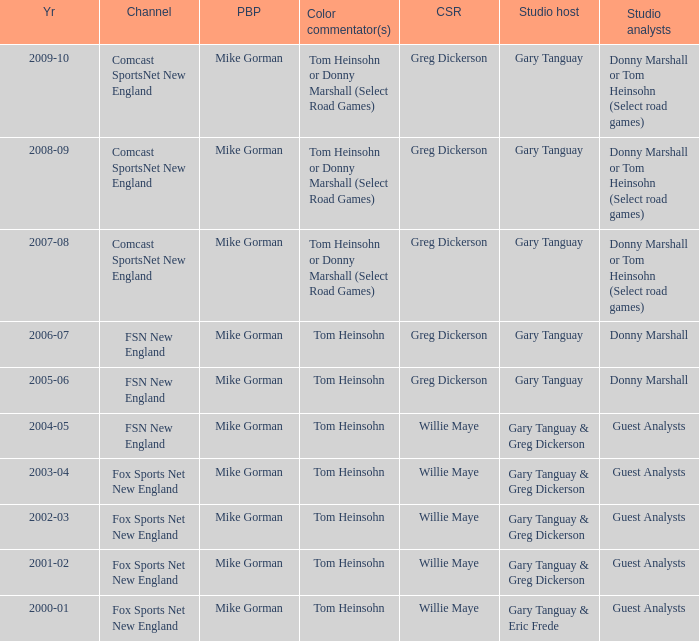Help me parse the entirety of this table. {'header': ['Yr', 'Channel', 'PBP', 'Color commentator(s)', 'CSR', 'Studio host', 'Studio analysts'], 'rows': [['2009-10', 'Comcast SportsNet New England', 'Mike Gorman', 'Tom Heinsohn or Donny Marshall (Select Road Games)', 'Greg Dickerson', 'Gary Tanguay', 'Donny Marshall or Tom Heinsohn (Select road games)'], ['2008-09', 'Comcast SportsNet New England', 'Mike Gorman', 'Tom Heinsohn or Donny Marshall (Select Road Games)', 'Greg Dickerson', 'Gary Tanguay', 'Donny Marshall or Tom Heinsohn (Select road games)'], ['2007-08', 'Comcast SportsNet New England', 'Mike Gorman', 'Tom Heinsohn or Donny Marshall (Select Road Games)', 'Greg Dickerson', 'Gary Tanguay', 'Donny Marshall or Tom Heinsohn (Select road games)'], ['2006-07', 'FSN New England', 'Mike Gorman', 'Tom Heinsohn', 'Greg Dickerson', 'Gary Tanguay', 'Donny Marshall'], ['2005-06', 'FSN New England', 'Mike Gorman', 'Tom Heinsohn', 'Greg Dickerson', 'Gary Tanguay', 'Donny Marshall'], ['2004-05', 'FSN New England', 'Mike Gorman', 'Tom Heinsohn', 'Willie Maye', 'Gary Tanguay & Greg Dickerson', 'Guest Analysts'], ['2003-04', 'Fox Sports Net New England', 'Mike Gorman', 'Tom Heinsohn', 'Willie Maye', 'Gary Tanguay & Greg Dickerson', 'Guest Analysts'], ['2002-03', 'Fox Sports Net New England', 'Mike Gorman', 'Tom Heinsohn', 'Willie Maye', 'Gary Tanguay & Greg Dickerson', 'Guest Analysts'], ['2001-02', 'Fox Sports Net New England', 'Mike Gorman', 'Tom Heinsohn', 'Willie Maye', 'Gary Tanguay & Greg Dickerson', 'Guest Analysts'], ['2000-01', 'Fox Sports Net New England', 'Mike Gorman', 'Tom Heinsohn', 'Willie Maye', 'Gary Tanguay & Eric Frede', 'Guest Analysts']]} WHich Studio host has a Year of 2003-04? Gary Tanguay & Greg Dickerson. 